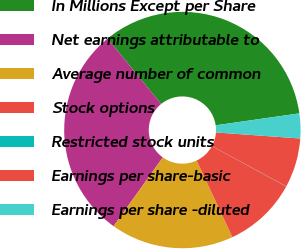Convert chart. <chart><loc_0><loc_0><loc_500><loc_500><pie_chart><fcel>In Millions Except per Share<fcel>Net earnings attributable to<fcel>Average number of common<fcel>Stock options<fcel>Restricted stock units<fcel>Earnings per share-basic<fcel>Earnings per share -diluted<nl><fcel>33.65%<fcel>29.21%<fcel>16.84%<fcel>10.12%<fcel>0.03%<fcel>6.76%<fcel>3.39%<nl></chart> 